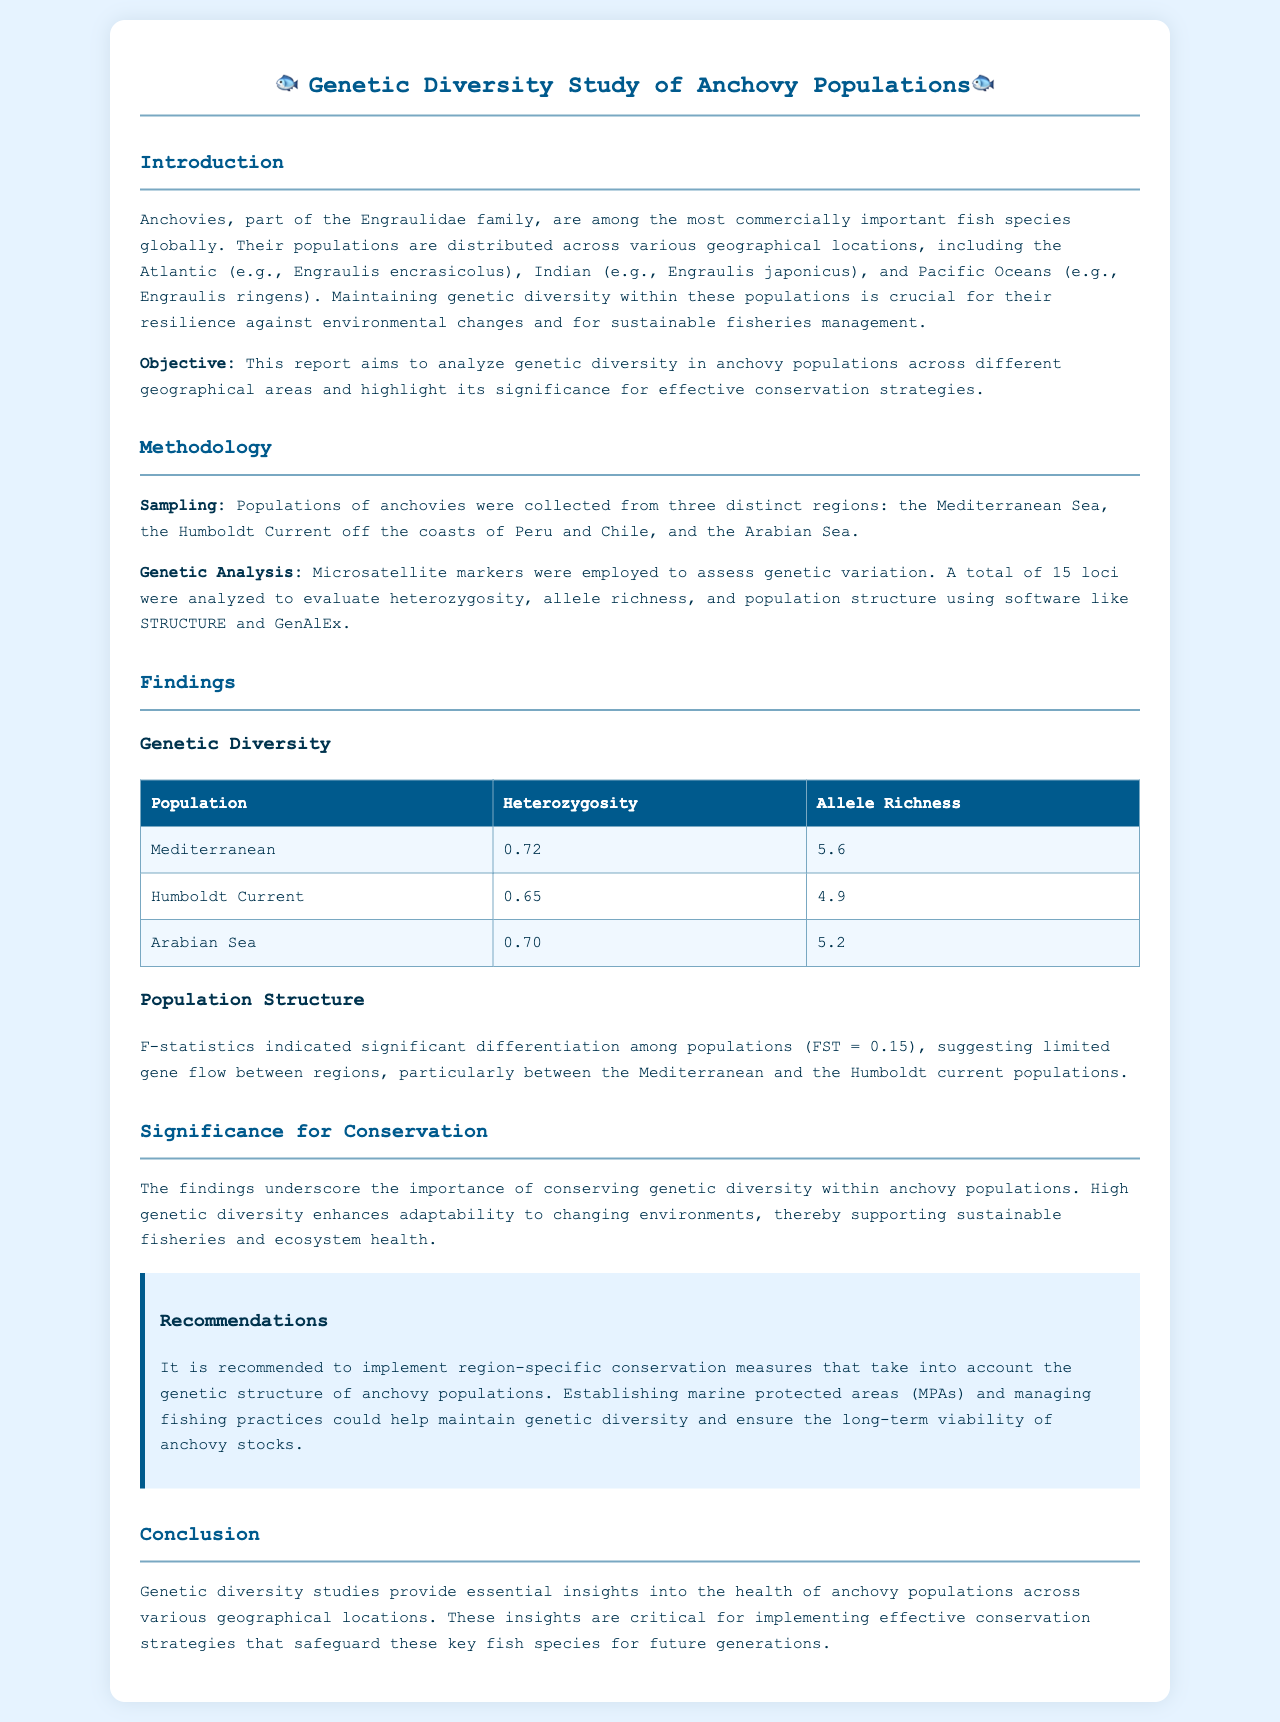What is the objective of the report? The objective is to analyze genetic diversity in anchovy populations across different geographical areas and highlight its significance for effective conservation strategies.
Answer: Analyze genetic diversity What methodology was used for genetic analysis? The report mentions that microsatellite markers were employed to assess genetic variation.
Answer: Microsatellite markers What is the heterozygosity of the Mediterranean anchovy population? The document states that the heterozygosity of the Mediterranean population is 0.72.
Answer: 0.72 What does FST value indicate in this report? The FST value of 0.15 indicates significant differentiation among populations, suggesting limited gene flow between regions.
Answer: Significant differentiation What is a recommended conservation measure mentioned in the document? The report recommends implementing region-specific conservation measures that take into account the genetic structure of anchor populations.
Answer: Marine protected areas Which population has the highest allele richness? The document specifies that the Mediterranean population has the highest allele richness at 5.6.
Answer: Mediterranean What is the allele richness of the Humboldt Current anchovy population? The document indicates that the allele richness of the Humboldt Current population is 4.9.
Answer: 4.9 Why is genetic diversity important for anchovy populations? The document emphasizes that high genetic diversity enhances adaptability to changing environments, supporting sustainable fisheries and ecosystem health.
Answer: Enhances adaptability 